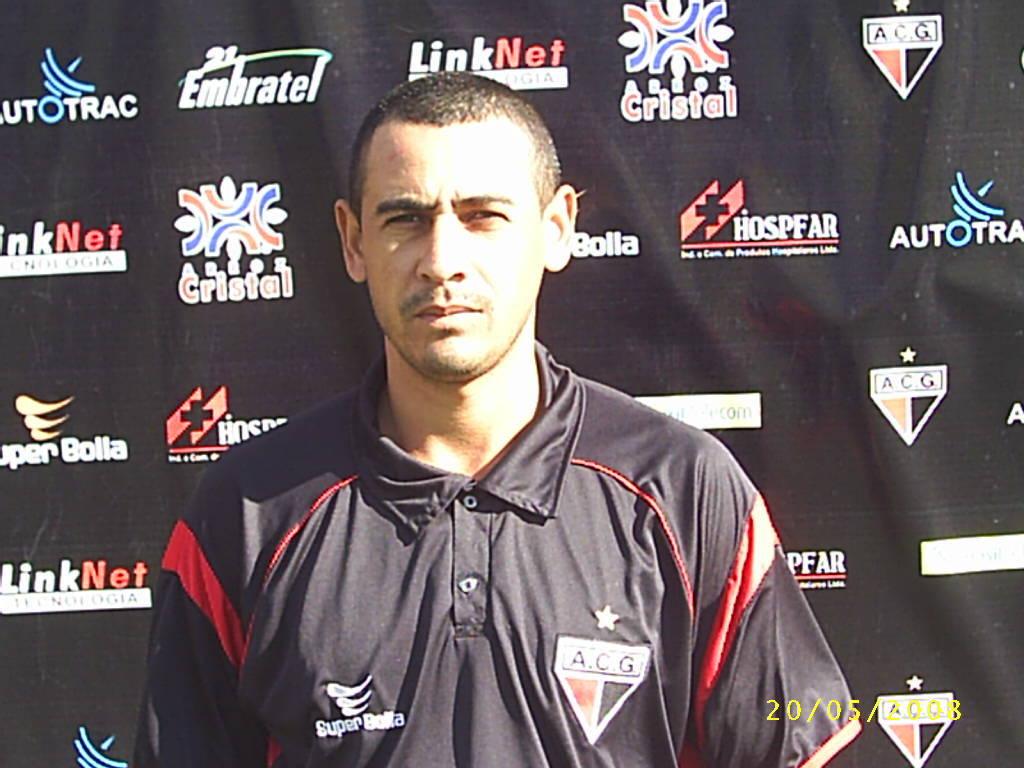What is a sponsor of this team?
Give a very brief answer. Super bolla. 